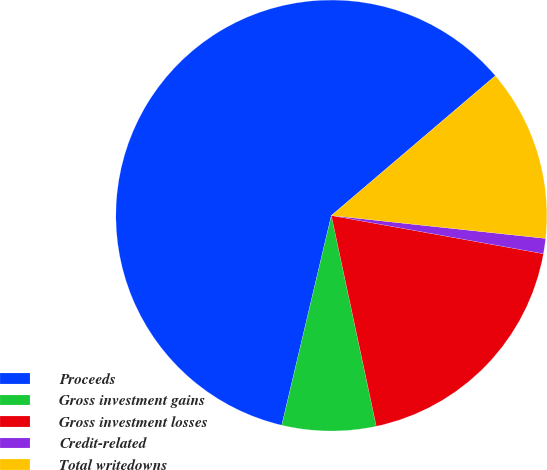Convert chart. <chart><loc_0><loc_0><loc_500><loc_500><pie_chart><fcel>Proceeds<fcel>Gross investment gains<fcel>Gross investment losses<fcel>Credit-related<fcel>Total writedowns<nl><fcel>60.07%<fcel>7.04%<fcel>18.82%<fcel>1.14%<fcel>12.93%<nl></chart> 